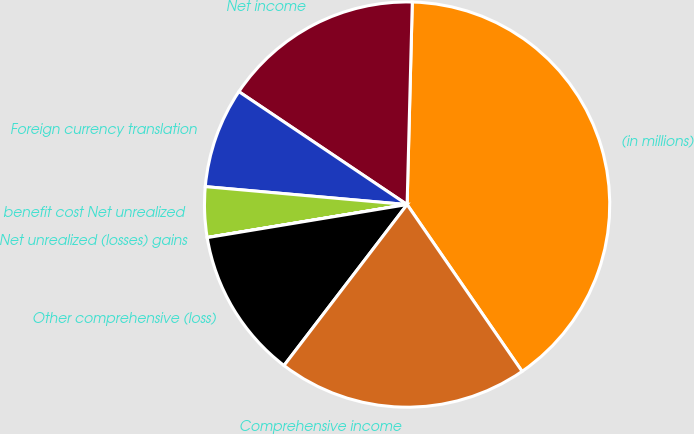Convert chart. <chart><loc_0><loc_0><loc_500><loc_500><pie_chart><fcel>(in millions)<fcel>Net income<fcel>Foreign currency translation<fcel>benefit cost Net unrealized<fcel>Net unrealized (losses) gains<fcel>Other comprehensive (loss)<fcel>Comprehensive income<nl><fcel>39.99%<fcel>16.0%<fcel>8.0%<fcel>4.01%<fcel>0.01%<fcel>12.0%<fcel>20.0%<nl></chart> 